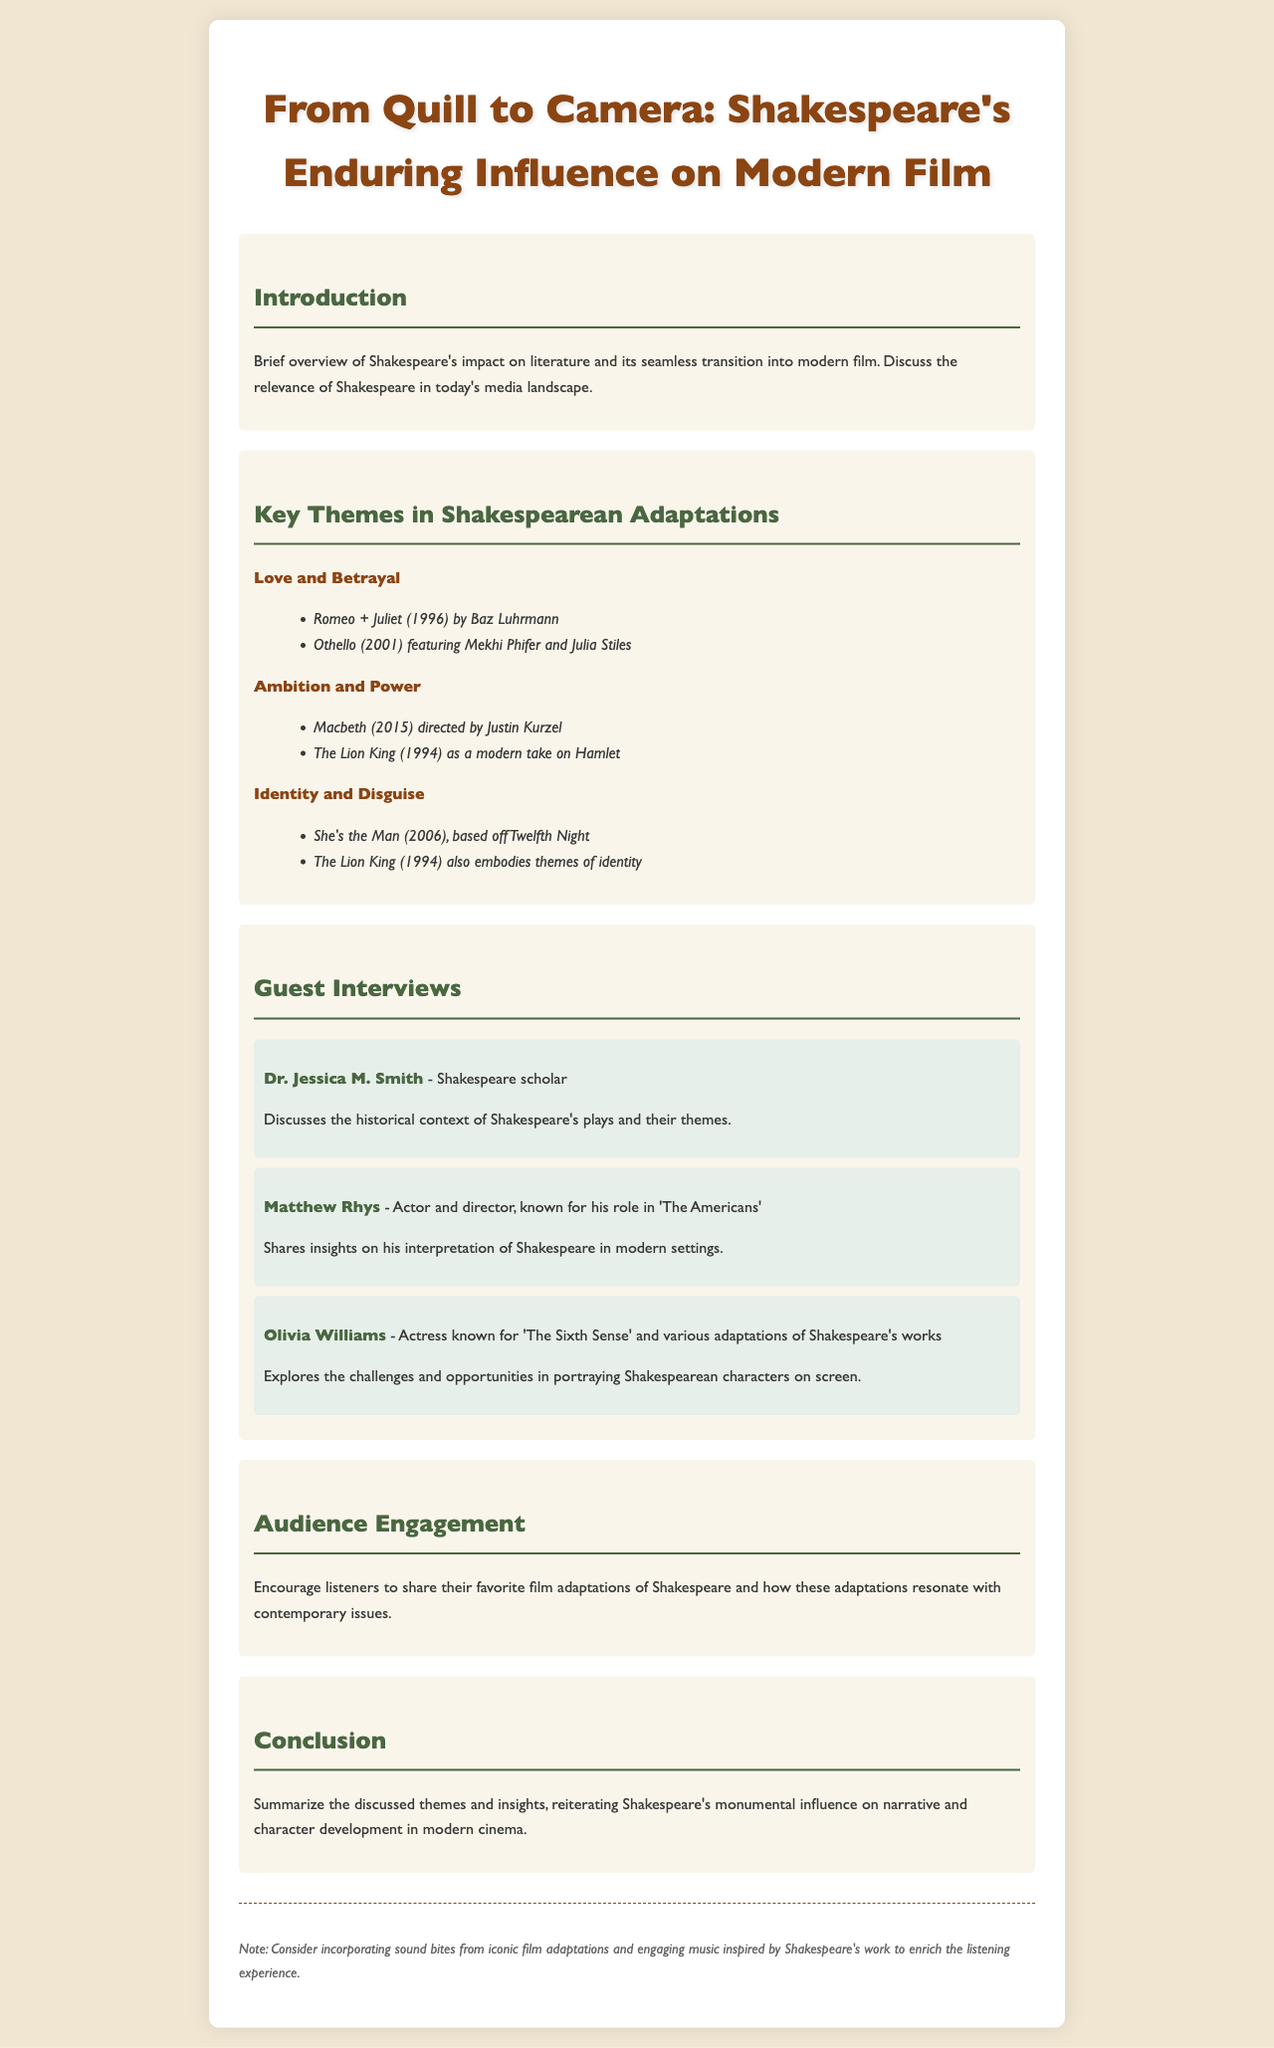What is the title of the podcast episode? The title of the podcast episode is mentioned at the top of the document.
Answer: From Quill to Camera: Shakespeare's Enduring Influence on Modern Film Who is one of the guests on the podcast? The document lists multiple guests in the Guest Interviews section.
Answer: Dr. Jessica M. Smith What theme does "Romeo + Juliet" represent? The theme associated with "Romeo + Juliet" is listed under Key Themes in Shakespearean Adaptations.
Answer: Love and Betrayal Which film is a modern take on Hamlet? The key themes include examples of adaptations, specifically mapping a modern film to its Shakespearean counterpart.
Answer: The Lion King What literary figure is the focus of the podcast episode? The document centers around the literary figure discussed throughout the episode.
Answer: Shakespeare How many main themes are discussed in the document? The document outlines several themes categorized under Key Themes in Shakespearean Adaptations.
Answer: Three What year's adaptation of Macbeth is mentioned? The year of the Macbeth adaptation is specified within the examples under Key Themes.
Answer: 2015 What is encouraged in the Audience Engagement section? The document suggests listener interaction in this particular segment.
Answer: Share their favorite film adaptations What aspect of Shakespeare's work is emphasized in the Conclusion? The conclusion summarizes the influence discussed throughout the episode.
Answer: Influence on narrative and character development 